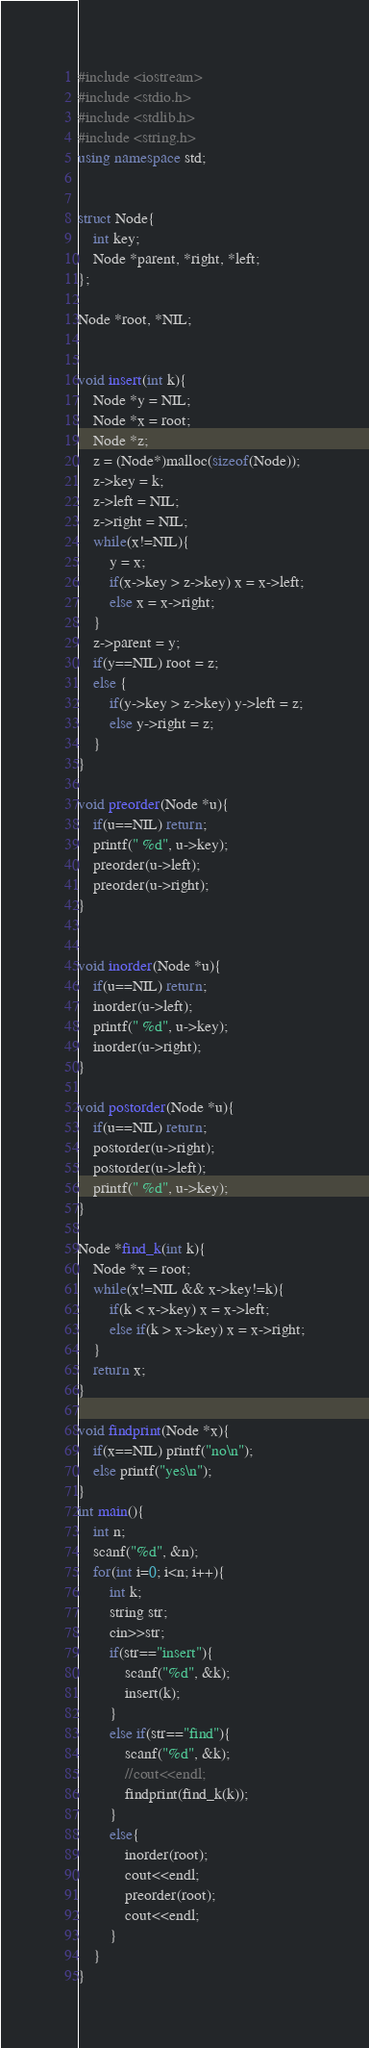<code> <loc_0><loc_0><loc_500><loc_500><_C++_>#include <iostream>
#include <stdio.h>
#include <stdlib.h>
#include <string.h>
using namespace std;


struct Node{
    int key;
    Node *parent, *right, *left;
};

Node *root, *NIL;


void insert(int k){
    Node *y = NIL;
    Node *x = root;
    Node *z;
    z = (Node*)malloc(sizeof(Node));
    z->key = k;
    z->left = NIL;
    z->right = NIL;
    while(x!=NIL){
        y = x;
        if(x->key > z->key) x = x->left;
        else x = x->right;
    }
    z->parent = y;
    if(y==NIL) root = z;
    else {
        if(y->key > z->key) y->left = z;
        else y->right = z;
    }
}

void preorder(Node *u){
    if(u==NIL) return;
    printf(" %d", u->key);
    preorder(u->left);
    preorder(u->right);
}


void inorder(Node *u){
    if(u==NIL) return;
    inorder(u->left);
    printf(" %d", u->key);
    inorder(u->right);
}

void postorder(Node *u){
    if(u==NIL) return;
    postorder(u->right);
    postorder(u->left);
    printf(" %d", u->key);
}

Node *find_k(int k){
    Node *x = root;
    while(x!=NIL && x->key!=k){
        if(k < x->key) x = x->left;
        else if(k > x->key) x = x->right;
    }
    return x;
}

void findprint(Node *x){
    if(x==NIL) printf("no\n");
    else printf("yes\n");
}
int main(){
    int n;
    scanf("%d", &n);
    for(int i=0; i<n; i++){
        int k;
        string str;
        cin>>str;
        if(str=="insert"){
            scanf("%d", &k);
            insert(k);
        }
        else if(str=="find"){
            scanf("%d", &k);
            //cout<<endl;
            findprint(find_k(k));
        }
        else{
            inorder(root);
            cout<<endl;
            preorder(root);
            cout<<endl;
        }
    }
}


</code> 